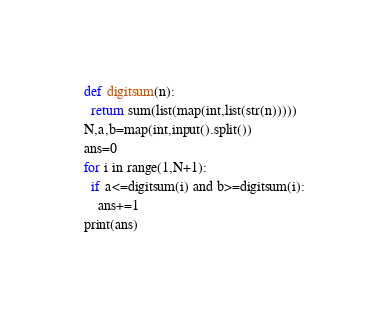<code> <loc_0><loc_0><loc_500><loc_500><_Python_>def digitsum(n):
  return sum(list(map(int,list(str(n)))))
N,a,b=map(int,input().split())
ans=0
for i in range(1,N+1):
  if a<=digitsum(i) and b>=digitsum(i):
    ans+=1
print(ans)</code> 